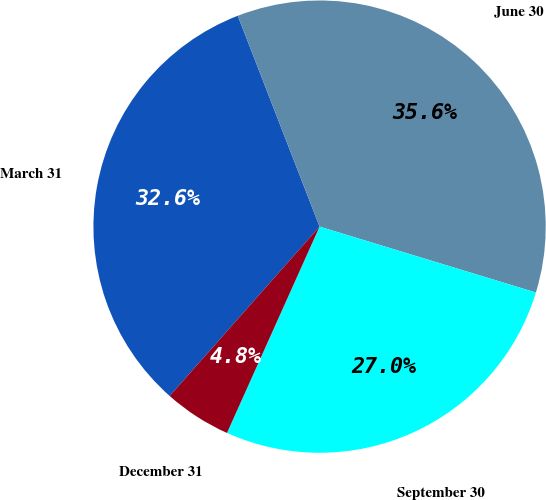Convert chart to OTSL. <chart><loc_0><loc_0><loc_500><loc_500><pie_chart><fcel>March 31<fcel>June 30<fcel>September 30<fcel>December 31<nl><fcel>32.58%<fcel>35.6%<fcel>27.01%<fcel>4.82%<nl></chart> 